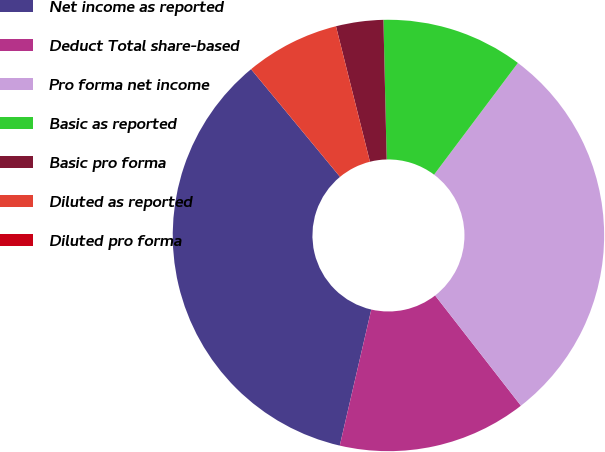Convert chart. <chart><loc_0><loc_0><loc_500><loc_500><pie_chart><fcel>Net income as reported<fcel>Deduct Total share-based<fcel>Pro forma net income<fcel>Basic as reported<fcel>Basic pro forma<fcel>Diluted as reported<fcel>Diluted pro forma<nl><fcel>35.39%<fcel>14.15%<fcel>29.23%<fcel>10.62%<fcel>3.54%<fcel>7.08%<fcel>0.0%<nl></chart> 